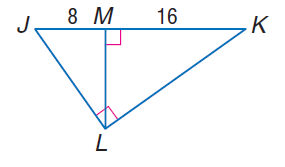Answer the mathemtical geometry problem and directly provide the correct option letter.
Question: Find the measure of the altitude drawn to the hypotenuse.
Choices: A: 8 B: 8 \sqrt { 2 } C: 16 D: 16 \sqrt { 2 } B 